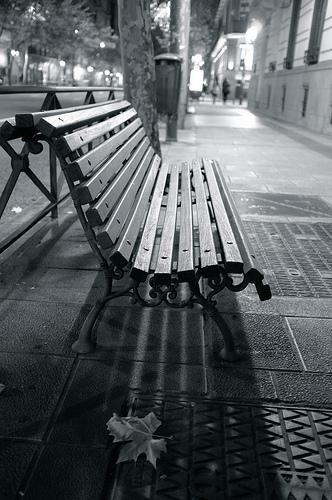Question: when was this taken?
Choices:
A. Daytime.
B. Noon.
C. Midnight.
D. Evening.
Answer with the letter. Answer: D Question: what is next to the railing?
Choices:
A. Pole.
B. Bench.
C. Sign.
D. Bucket.
Answer with the letter. Answer: B Question: who is on the bench?
Choices:
A. Girl.
B. Bird.
C. No one.
D. Duck.
Answer with the letter. Answer: C Question: what is behind the bench?
Choices:
A. Duck.
B. Bird.
C. Rabbit.
D. Tree.
Answer with the letter. Answer: D 